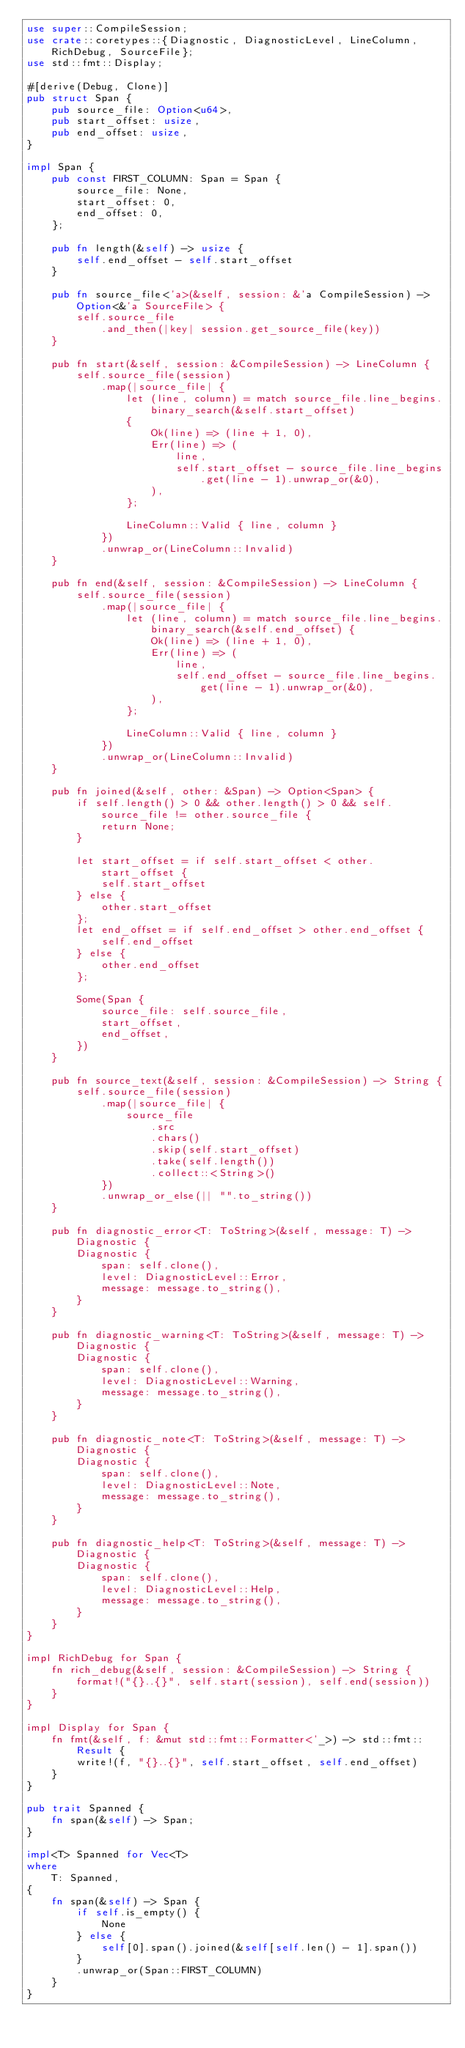<code> <loc_0><loc_0><loc_500><loc_500><_Rust_>use super::CompileSession;
use crate::coretypes::{Diagnostic, DiagnosticLevel, LineColumn, RichDebug, SourceFile};
use std::fmt::Display;

#[derive(Debug, Clone)]
pub struct Span {
    pub source_file: Option<u64>,
    pub start_offset: usize,
    pub end_offset: usize,
}

impl Span {
    pub const FIRST_COLUMN: Span = Span {
        source_file: None,
        start_offset: 0,
        end_offset: 0,
    };

    pub fn length(&self) -> usize {
        self.end_offset - self.start_offset
    }

    pub fn source_file<'a>(&self, session: &'a CompileSession) -> Option<&'a SourceFile> {
        self.source_file
            .and_then(|key| session.get_source_file(key))
    }

    pub fn start(&self, session: &CompileSession) -> LineColumn {
        self.source_file(session)
            .map(|source_file| {
                let (line, column) = match source_file.line_begins.binary_search(&self.start_offset)
                {
                    Ok(line) => (line + 1, 0),
                    Err(line) => (
                        line,
                        self.start_offset - source_file.line_begins.get(line - 1).unwrap_or(&0),
                    ),
                };

                LineColumn::Valid { line, column }
            })
            .unwrap_or(LineColumn::Invalid)
    }

    pub fn end(&self, session: &CompileSession) -> LineColumn {
        self.source_file(session)
            .map(|source_file| {
                let (line, column) = match source_file.line_begins.binary_search(&self.end_offset) {
                    Ok(line) => (line + 1, 0),
                    Err(line) => (
                        line,
                        self.end_offset - source_file.line_begins.get(line - 1).unwrap_or(&0),
                    ),
                };

                LineColumn::Valid { line, column }
            })
            .unwrap_or(LineColumn::Invalid)
    }

    pub fn joined(&self, other: &Span) -> Option<Span> {
        if self.length() > 0 && other.length() > 0 && self.source_file != other.source_file {
            return None;
        }

        let start_offset = if self.start_offset < other.start_offset {
            self.start_offset
        } else {
            other.start_offset
        };
        let end_offset = if self.end_offset > other.end_offset {
            self.end_offset
        } else {
            other.end_offset
        };

        Some(Span {
            source_file: self.source_file,
            start_offset,
            end_offset,
        })
    }

    pub fn source_text(&self, session: &CompileSession) -> String {
        self.source_file(session)
            .map(|source_file| {
                source_file
                    .src
                    .chars()
                    .skip(self.start_offset)
                    .take(self.length())
                    .collect::<String>()
            })
            .unwrap_or_else(|| "".to_string())
    }

    pub fn diagnostic_error<T: ToString>(&self, message: T) -> Diagnostic {
        Diagnostic {
            span: self.clone(),
            level: DiagnosticLevel::Error,
            message: message.to_string(),
        }
    }

    pub fn diagnostic_warning<T: ToString>(&self, message: T) -> Diagnostic {
        Diagnostic {
            span: self.clone(),
            level: DiagnosticLevel::Warning,
            message: message.to_string(),
        }
    }

    pub fn diagnostic_note<T: ToString>(&self, message: T) -> Diagnostic {
        Diagnostic {
            span: self.clone(),
            level: DiagnosticLevel::Note,
            message: message.to_string(),
        }
    }

    pub fn diagnostic_help<T: ToString>(&self, message: T) -> Diagnostic {
        Diagnostic {
            span: self.clone(),
            level: DiagnosticLevel::Help,
            message: message.to_string(),
        }
    }
}

impl RichDebug for Span {
    fn rich_debug(&self, session: &CompileSession) -> String {
        format!("{}..{}", self.start(session), self.end(session))
    }
}

impl Display for Span {
    fn fmt(&self, f: &mut std::fmt::Formatter<'_>) -> std::fmt::Result {
        write!(f, "{}..{}", self.start_offset, self.end_offset)
    }
}

pub trait Spanned {
    fn span(&self) -> Span;
}

impl<T> Spanned for Vec<T>
where
    T: Spanned,
{
    fn span(&self) -> Span {
        if self.is_empty() {
            None
        } else {
            self[0].span().joined(&self[self.len() - 1].span())
        }
        .unwrap_or(Span::FIRST_COLUMN)
    }
}
</code> 